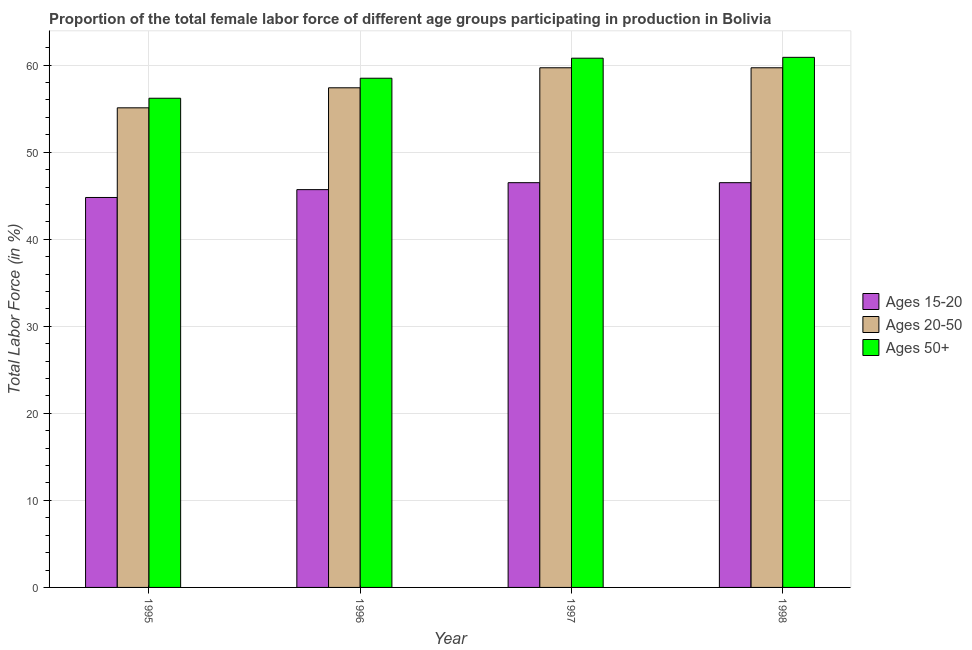Are the number of bars on each tick of the X-axis equal?
Offer a terse response. Yes. How many bars are there on the 1st tick from the left?
Your response must be concise. 3. How many bars are there on the 3rd tick from the right?
Provide a short and direct response. 3. What is the percentage of female labor force within the age group 15-20 in 1998?
Keep it short and to the point. 46.5. Across all years, what is the maximum percentage of female labor force above age 50?
Your response must be concise. 60.9. Across all years, what is the minimum percentage of female labor force above age 50?
Ensure brevity in your answer.  56.2. What is the total percentage of female labor force within the age group 20-50 in the graph?
Make the answer very short. 231.9. What is the difference between the percentage of female labor force within the age group 20-50 in 1995 and that in 1997?
Make the answer very short. -4.6. What is the difference between the percentage of female labor force above age 50 in 1997 and the percentage of female labor force within the age group 20-50 in 1995?
Make the answer very short. 4.6. What is the average percentage of female labor force within the age group 20-50 per year?
Provide a succinct answer. 57.98. What is the ratio of the percentage of female labor force within the age group 15-20 in 1995 to that in 1996?
Your answer should be very brief. 0.98. Is the difference between the percentage of female labor force within the age group 15-20 in 1996 and 1997 greater than the difference between the percentage of female labor force above age 50 in 1996 and 1997?
Your answer should be compact. No. What is the difference between the highest and the second highest percentage of female labor force above age 50?
Keep it short and to the point. 0.1. What is the difference between the highest and the lowest percentage of female labor force within the age group 15-20?
Offer a terse response. 1.7. In how many years, is the percentage of female labor force within the age group 15-20 greater than the average percentage of female labor force within the age group 15-20 taken over all years?
Offer a terse response. 2. Is the sum of the percentage of female labor force within the age group 20-50 in 1995 and 1996 greater than the maximum percentage of female labor force above age 50 across all years?
Give a very brief answer. Yes. What does the 3rd bar from the left in 1997 represents?
Offer a terse response. Ages 50+. What does the 1st bar from the right in 1998 represents?
Ensure brevity in your answer.  Ages 50+. How many bars are there?
Ensure brevity in your answer.  12. How many years are there in the graph?
Your answer should be compact. 4. What is the difference between two consecutive major ticks on the Y-axis?
Offer a very short reply. 10. Does the graph contain any zero values?
Keep it short and to the point. No. Does the graph contain grids?
Offer a terse response. Yes. How are the legend labels stacked?
Ensure brevity in your answer.  Vertical. What is the title of the graph?
Keep it short and to the point. Proportion of the total female labor force of different age groups participating in production in Bolivia. What is the label or title of the X-axis?
Provide a succinct answer. Year. What is the Total Labor Force (in %) in Ages 15-20 in 1995?
Give a very brief answer. 44.8. What is the Total Labor Force (in %) in Ages 20-50 in 1995?
Your answer should be very brief. 55.1. What is the Total Labor Force (in %) in Ages 50+ in 1995?
Your response must be concise. 56.2. What is the Total Labor Force (in %) in Ages 15-20 in 1996?
Keep it short and to the point. 45.7. What is the Total Labor Force (in %) of Ages 20-50 in 1996?
Your response must be concise. 57.4. What is the Total Labor Force (in %) of Ages 50+ in 1996?
Offer a very short reply. 58.5. What is the Total Labor Force (in %) of Ages 15-20 in 1997?
Keep it short and to the point. 46.5. What is the Total Labor Force (in %) of Ages 20-50 in 1997?
Provide a short and direct response. 59.7. What is the Total Labor Force (in %) of Ages 50+ in 1997?
Keep it short and to the point. 60.8. What is the Total Labor Force (in %) of Ages 15-20 in 1998?
Provide a short and direct response. 46.5. What is the Total Labor Force (in %) in Ages 20-50 in 1998?
Your response must be concise. 59.7. What is the Total Labor Force (in %) in Ages 50+ in 1998?
Ensure brevity in your answer.  60.9. Across all years, what is the maximum Total Labor Force (in %) in Ages 15-20?
Your answer should be very brief. 46.5. Across all years, what is the maximum Total Labor Force (in %) in Ages 20-50?
Offer a terse response. 59.7. Across all years, what is the maximum Total Labor Force (in %) of Ages 50+?
Give a very brief answer. 60.9. Across all years, what is the minimum Total Labor Force (in %) of Ages 15-20?
Your answer should be compact. 44.8. Across all years, what is the minimum Total Labor Force (in %) of Ages 20-50?
Provide a short and direct response. 55.1. Across all years, what is the minimum Total Labor Force (in %) in Ages 50+?
Your response must be concise. 56.2. What is the total Total Labor Force (in %) in Ages 15-20 in the graph?
Your answer should be very brief. 183.5. What is the total Total Labor Force (in %) in Ages 20-50 in the graph?
Offer a terse response. 231.9. What is the total Total Labor Force (in %) of Ages 50+ in the graph?
Provide a succinct answer. 236.4. What is the difference between the Total Labor Force (in %) in Ages 15-20 in 1995 and that in 1996?
Your answer should be compact. -0.9. What is the difference between the Total Labor Force (in %) of Ages 20-50 in 1995 and that in 1996?
Your answer should be compact. -2.3. What is the difference between the Total Labor Force (in %) of Ages 50+ in 1995 and that in 1996?
Your answer should be very brief. -2.3. What is the difference between the Total Labor Force (in %) in Ages 15-20 in 1995 and that in 1998?
Make the answer very short. -1.7. What is the difference between the Total Labor Force (in %) of Ages 50+ in 1995 and that in 1998?
Offer a terse response. -4.7. What is the difference between the Total Labor Force (in %) of Ages 15-20 in 1996 and that in 1997?
Ensure brevity in your answer.  -0.8. What is the difference between the Total Labor Force (in %) of Ages 20-50 in 1996 and that in 1998?
Offer a terse response. -2.3. What is the difference between the Total Labor Force (in %) of Ages 15-20 in 1997 and that in 1998?
Ensure brevity in your answer.  0. What is the difference between the Total Labor Force (in %) of Ages 50+ in 1997 and that in 1998?
Give a very brief answer. -0.1. What is the difference between the Total Labor Force (in %) of Ages 15-20 in 1995 and the Total Labor Force (in %) of Ages 50+ in 1996?
Give a very brief answer. -13.7. What is the difference between the Total Labor Force (in %) in Ages 15-20 in 1995 and the Total Labor Force (in %) in Ages 20-50 in 1997?
Give a very brief answer. -14.9. What is the difference between the Total Labor Force (in %) of Ages 15-20 in 1995 and the Total Labor Force (in %) of Ages 50+ in 1997?
Your answer should be very brief. -16. What is the difference between the Total Labor Force (in %) of Ages 15-20 in 1995 and the Total Labor Force (in %) of Ages 20-50 in 1998?
Provide a succinct answer. -14.9. What is the difference between the Total Labor Force (in %) in Ages 15-20 in 1995 and the Total Labor Force (in %) in Ages 50+ in 1998?
Provide a succinct answer. -16.1. What is the difference between the Total Labor Force (in %) in Ages 15-20 in 1996 and the Total Labor Force (in %) in Ages 50+ in 1997?
Your answer should be very brief. -15.1. What is the difference between the Total Labor Force (in %) of Ages 15-20 in 1996 and the Total Labor Force (in %) of Ages 50+ in 1998?
Provide a succinct answer. -15.2. What is the difference between the Total Labor Force (in %) in Ages 20-50 in 1996 and the Total Labor Force (in %) in Ages 50+ in 1998?
Your response must be concise. -3.5. What is the difference between the Total Labor Force (in %) of Ages 15-20 in 1997 and the Total Labor Force (in %) of Ages 20-50 in 1998?
Keep it short and to the point. -13.2. What is the difference between the Total Labor Force (in %) in Ages 15-20 in 1997 and the Total Labor Force (in %) in Ages 50+ in 1998?
Offer a terse response. -14.4. What is the average Total Labor Force (in %) in Ages 15-20 per year?
Your answer should be compact. 45.88. What is the average Total Labor Force (in %) in Ages 20-50 per year?
Keep it short and to the point. 57.98. What is the average Total Labor Force (in %) in Ages 50+ per year?
Keep it short and to the point. 59.1. In the year 1995, what is the difference between the Total Labor Force (in %) in Ages 15-20 and Total Labor Force (in %) in Ages 50+?
Offer a very short reply. -11.4. In the year 1996, what is the difference between the Total Labor Force (in %) of Ages 15-20 and Total Labor Force (in %) of Ages 20-50?
Make the answer very short. -11.7. In the year 1996, what is the difference between the Total Labor Force (in %) in Ages 15-20 and Total Labor Force (in %) in Ages 50+?
Make the answer very short. -12.8. In the year 1997, what is the difference between the Total Labor Force (in %) in Ages 15-20 and Total Labor Force (in %) in Ages 50+?
Offer a very short reply. -14.3. In the year 1998, what is the difference between the Total Labor Force (in %) in Ages 15-20 and Total Labor Force (in %) in Ages 50+?
Your answer should be very brief. -14.4. In the year 1998, what is the difference between the Total Labor Force (in %) of Ages 20-50 and Total Labor Force (in %) of Ages 50+?
Offer a terse response. -1.2. What is the ratio of the Total Labor Force (in %) in Ages 15-20 in 1995 to that in 1996?
Your answer should be compact. 0.98. What is the ratio of the Total Labor Force (in %) in Ages 20-50 in 1995 to that in 1996?
Give a very brief answer. 0.96. What is the ratio of the Total Labor Force (in %) of Ages 50+ in 1995 to that in 1996?
Offer a very short reply. 0.96. What is the ratio of the Total Labor Force (in %) in Ages 15-20 in 1995 to that in 1997?
Provide a short and direct response. 0.96. What is the ratio of the Total Labor Force (in %) of Ages 20-50 in 1995 to that in 1997?
Your response must be concise. 0.92. What is the ratio of the Total Labor Force (in %) of Ages 50+ in 1995 to that in 1997?
Offer a terse response. 0.92. What is the ratio of the Total Labor Force (in %) of Ages 15-20 in 1995 to that in 1998?
Provide a short and direct response. 0.96. What is the ratio of the Total Labor Force (in %) of Ages 20-50 in 1995 to that in 1998?
Provide a succinct answer. 0.92. What is the ratio of the Total Labor Force (in %) of Ages 50+ in 1995 to that in 1998?
Provide a succinct answer. 0.92. What is the ratio of the Total Labor Force (in %) of Ages 15-20 in 1996 to that in 1997?
Provide a succinct answer. 0.98. What is the ratio of the Total Labor Force (in %) of Ages 20-50 in 1996 to that in 1997?
Ensure brevity in your answer.  0.96. What is the ratio of the Total Labor Force (in %) in Ages 50+ in 1996 to that in 1997?
Your answer should be compact. 0.96. What is the ratio of the Total Labor Force (in %) in Ages 15-20 in 1996 to that in 1998?
Your response must be concise. 0.98. What is the ratio of the Total Labor Force (in %) in Ages 20-50 in 1996 to that in 1998?
Ensure brevity in your answer.  0.96. What is the ratio of the Total Labor Force (in %) in Ages 50+ in 1996 to that in 1998?
Your answer should be very brief. 0.96. What is the ratio of the Total Labor Force (in %) of Ages 20-50 in 1997 to that in 1998?
Your response must be concise. 1. What is the difference between the highest and the lowest Total Labor Force (in %) of Ages 15-20?
Provide a succinct answer. 1.7. What is the difference between the highest and the lowest Total Labor Force (in %) of Ages 50+?
Your answer should be very brief. 4.7. 